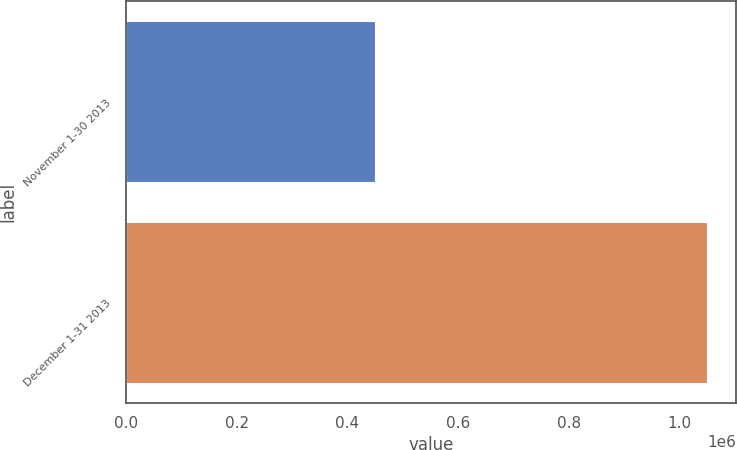Convert chart. <chart><loc_0><loc_0><loc_500><loc_500><bar_chart><fcel>November 1-30 2013<fcel>December 1-31 2013<nl><fcel>450000<fcel>1.05e+06<nl></chart> 